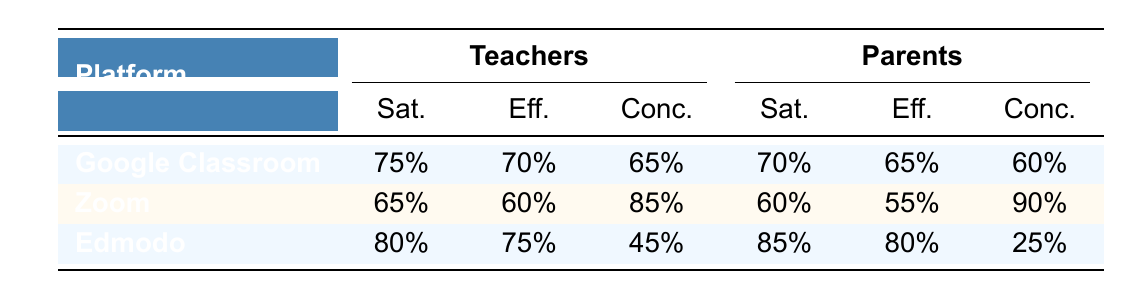What is the satisfaction percentage for teachers using Google Classroom? The table shows that the satisfaction percentage for teachers using Google Classroom is 75%. This value can be directly found under the "Sat." column for the "Google Classroom" row labeled "Teachers."
Answer: 75% Which platform received the highest effectiveness score from parents? The effectiveness scores for parents are as follows: Google Classroom (65%), Zoom (55%), and Edmodo (80%). The highest score is 80% for Edmodo, which can be seen in the "Eff." column of the "Edmodo" row labeled "Parents."
Answer: Edmodo What is the average satisfaction score for teachers across all platforms? The satisfaction percentages for teachers are 75% for Google Classroom, 65% for Zoom, and 80% for Edmodo. The average is calculated as (75 + 65 + 80) / 3 = 220 / 3 = 73.33, which can be summarized to two decimal places.
Answer: 73.33% Is there a platform that both teachers and parents gave higher satisfaction ratings to? Yes, both groups rated Edmodo higher in satisfaction, with teachers giving it 80% and parents giving it 85%. This confirms that Edmodo received the highest satisfaction scores from both groups.
Answer: Yes Which group expressed more concerns about communication regarding Zoom? The concerns about communication for Zoom are listed as 25% for teachers and 30% for parents. Since 30% (parents) is higher than 25% (teachers), it indicates that parents expressed more concerns regarding communication on Zoom.
Answer: Parents What is the difference in effectiveness scores between the best-rated platform for teachers and that for parents? The highest effectiveness score for teachers is 75% for Edmodo, while for parents, it is 80% for Edmodo. The difference is calculated as 80 - 75 = 5%. Therefore, parents rated their best platform 5% higher than teachers.
Answer: 5% Which platform had the lowest average effectiveness score between teachers and parents? The effectiveness scores are 70% for Google Classroom (Teachers) and 65% (Parents), 60% for Zoom (Teachers) and 55% (Parents), and 75% for Edmodo (Teachers) and 80% (Parents). The averages for Google Classroom (67.5%), Zoom (57.5%), and Edmodo (77.5%) indicate that Zoom has the lowest average effectiveness score at 57.5%.
Answer: Zoom 